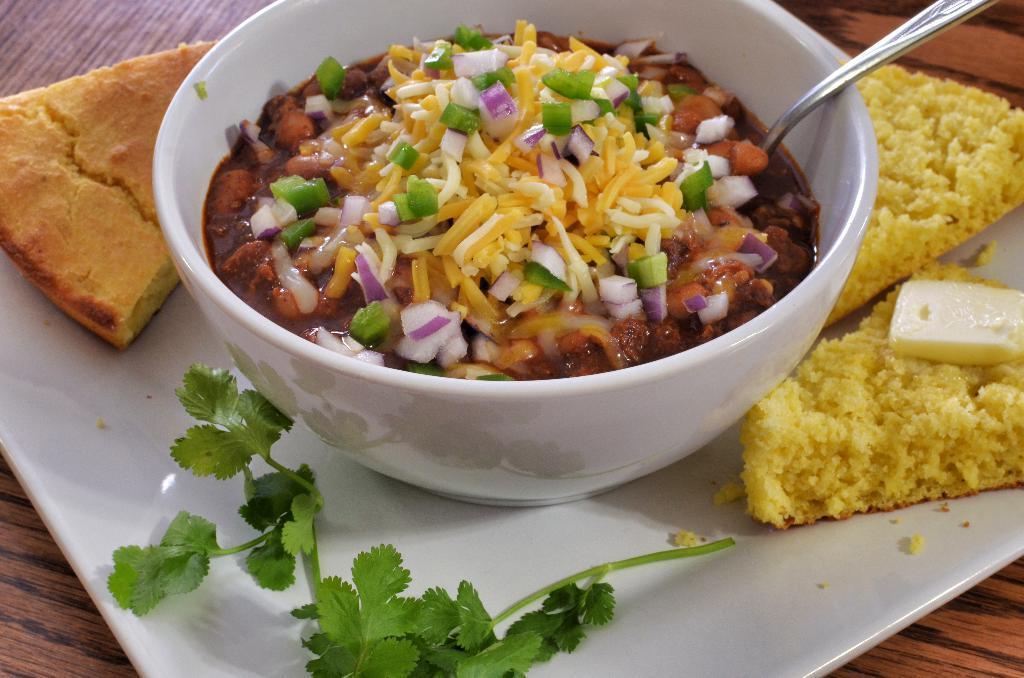Could you give a brief overview of what you see in this image? On a wooden platform we can see food and coriander leaves in a plate. In this bowl we can see food and a spoon. 